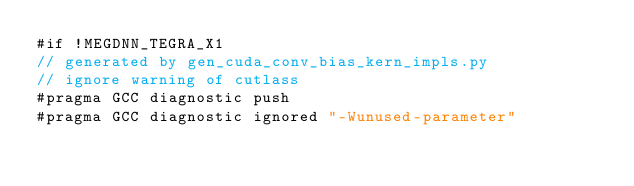<code> <loc_0><loc_0><loc_500><loc_500><_Cuda_>#if !MEGDNN_TEGRA_X1
// generated by gen_cuda_conv_bias_kern_impls.py
// ignore warning of cutlass
#pragma GCC diagnostic push
#pragma GCC diagnostic ignored "-Wunused-parameter"</code> 